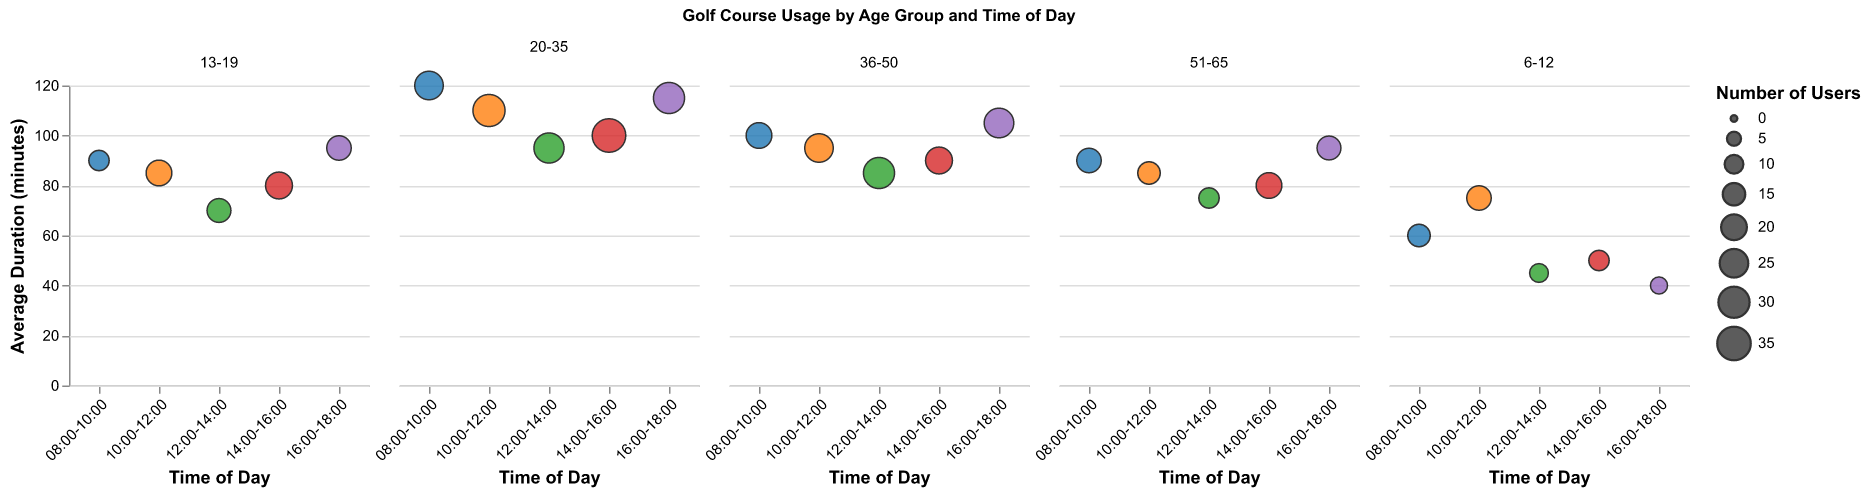What time of day does the 6-12 age group have the highest number of users? By comparing the size of the bubbles corresponding to each time period for the 6-12 age group, the largest bubble (indicating the highest number of users) is observed in the 10:00-12:00 time slot.
Answer: 10:00-12:00 How many users are there in total for the 13-19 age group throughout the day? Sum the number of users for each time period in the 13-19 age group: 12 + 20 + 17 + 22 + 18 = 89 users.
Answer: 89 At what time of day does the age group 20-35 spend the longest average duration on the golf course? Observing the y-axis, the bubble corresponding to the longest average duration (highest point) for the 20-35 age group is during 08:00-10:00 with an average duration of 120 minutes.
Answer: 08:00-10:00 Which age group has the most users during the 14:00-16:00 time slot? Comparing the bubbles for the 14:00-16:00 time slot across all age groups, the 20-35 age group has the largest bubble, indicating the highest number of users (35 users).
Answer: 20-35 What's the difference in the number of users between the 10:00-12:00 and 16:00-18:00 time slots for the 36-50 age group? Subtract the number of users at 16:00-18:00 (27) from the number of users at 10:00-12:00 (25) for the 36-50 age group: 27 - 25 = 2.
Answer: 2 Which age group spends the least time on average at the golf course during the 12:00-14:00 time slot? Observing the y-axis, the bubble with the lowest position for the 12:00-14:00 slot corresponds to the 6-12 age group with an average duration of 45 minutes.
Answer: 6-12 Is the number of users at any time slot greater for the 36-50 age group compared to the 20-35 age group? Comparing each time slot, the number of users for the 20-35 age group is greater than or equal to the number of users in the 36-50 age group in all time slots, e.g., 35 (20-35) vs. 22 (36-50) at 14:00-16:00.
Answer: No What is the average duration spent on the golf course by the 51-65 age group between 10:00-12:00 and 12:00-14:00? Calculate the average of the durations for 10:00-12:00 (85 minutes) and 12:00-14:00 (75 minutes): (85 + 75) / 2 = 80 minutes.
Answer: 80 